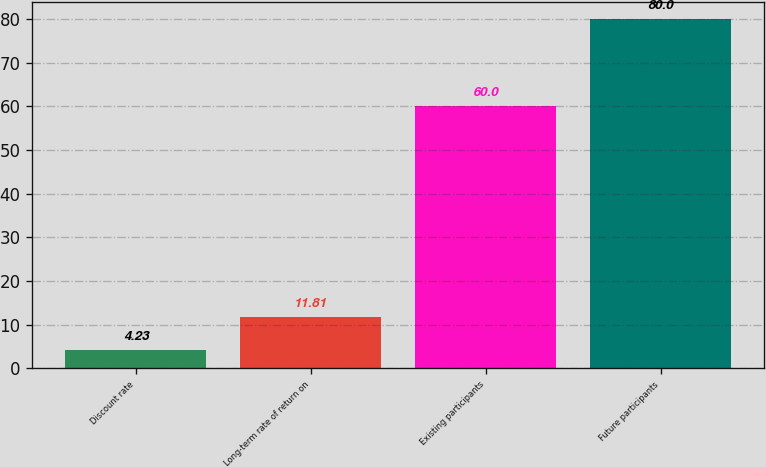Convert chart. <chart><loc_0><loc_0><loc_500><loc_500><bar_chart><fcel>Discount rate<fcel>Long-term rate of return on<fcel>Existing participants<fcel>Future participants<nl><fcel>4.23<fcel>11.81<fcel>60<fcel>80<nl></chart> 